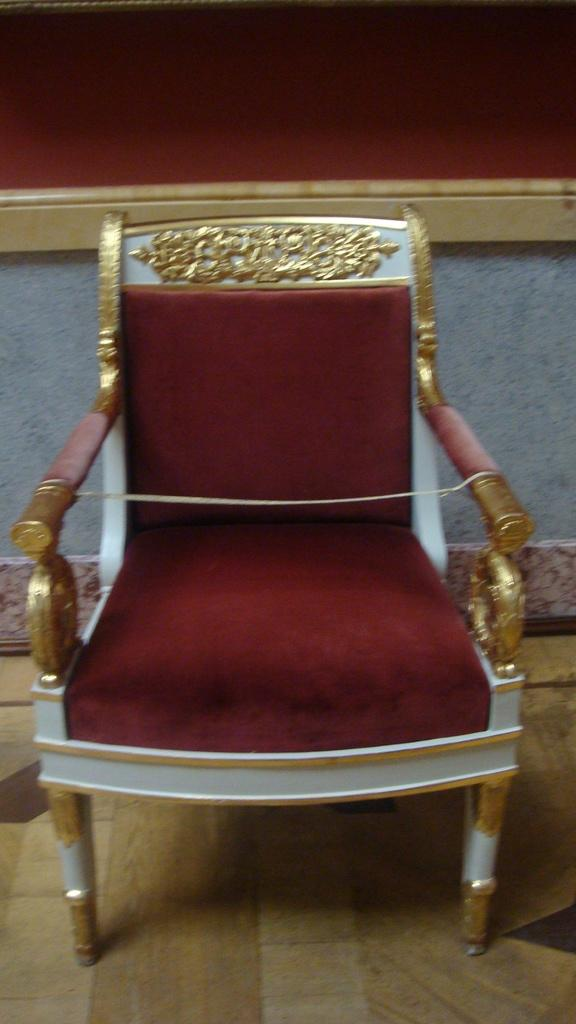What type of chair is in the image? There is a red color relaxing chair in the image. What is the flooring material in the image? The chair is placed on wooden flooring. What can be seen in the background of the image? There is a red color cushion wall in the background of the image. Can you see any loaves of bread on the wooden flooring in the image? No, there are no loaves of bread present in the image. 